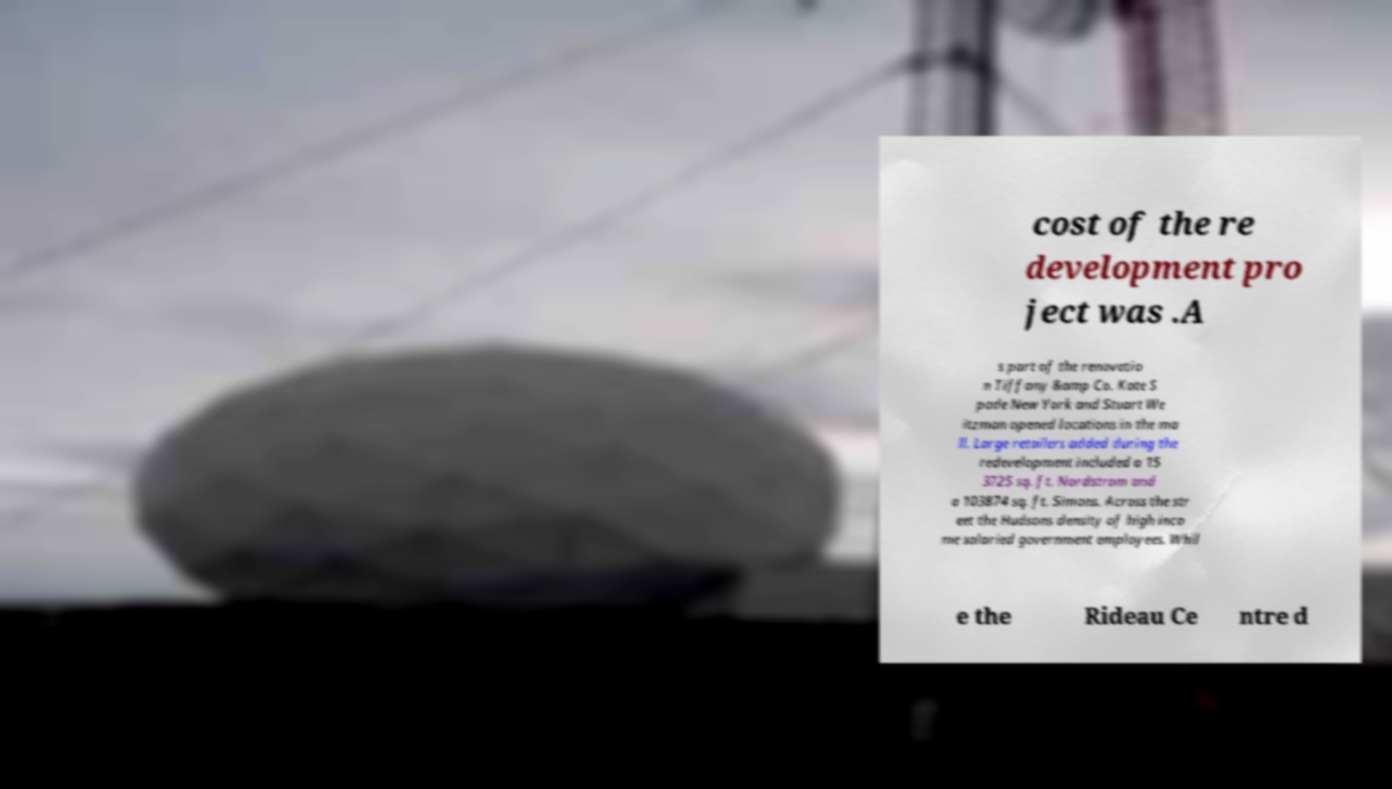I need the written content from this picture converted into text. Can you do that? cost of the re development pro ject was .A s part of the renovatio n Tiffany &amp Co. Kate S pade New York and Stuart We itzman opened locations in the ma ll. Large retailers added during the redevelopment included a 15 3725 sq. ft. Nordstrom and a 103874 sq. ft. Simons. Across the str eet the Hudsons density of high inco me salaried government employees. Whil e the Rideau Ce ntre d 